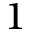<formula> <loc_0><loc_0><loc_500><loc_500>1</formula> 